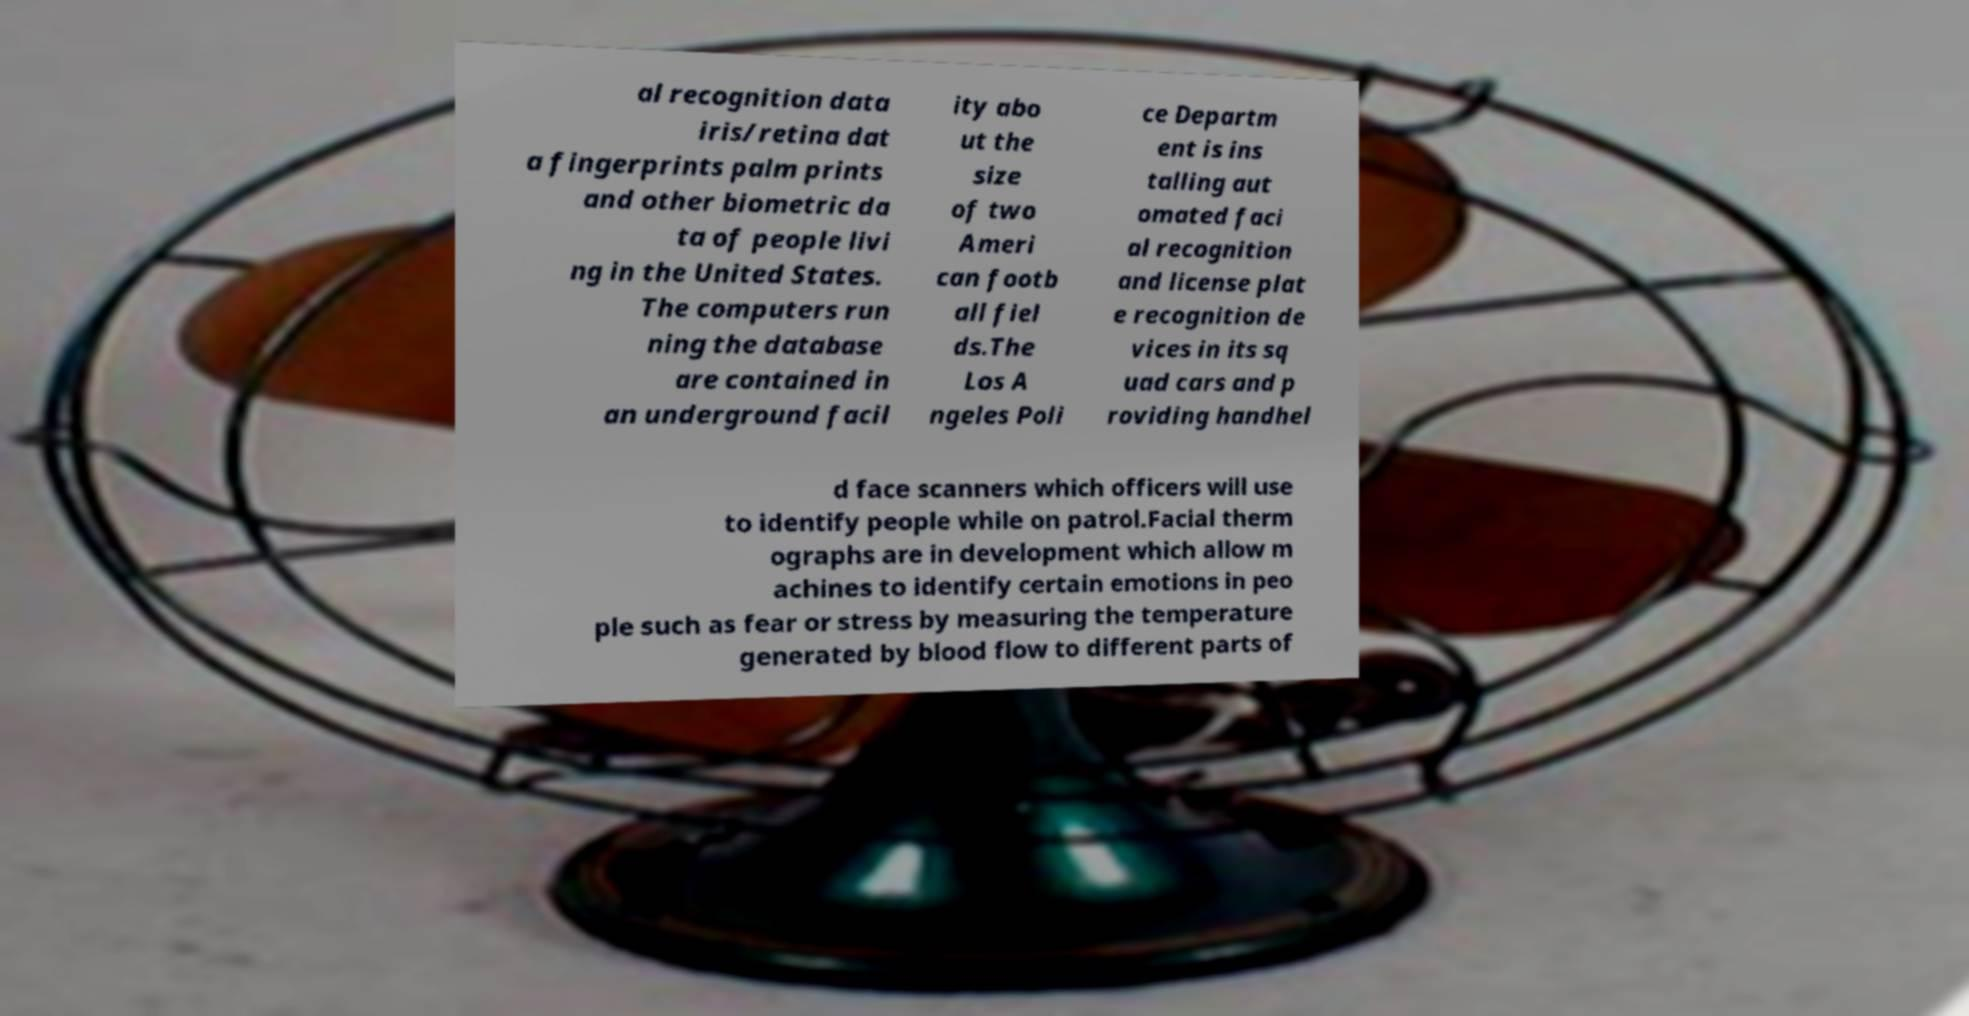Can you read and provide the text displayed in the image?This photo seems to have some interesting text. Can you extract and type it out for me? al recognition data iris/retina dat a fingerprints palm prints and other biometric da ta of people livi ng in the United States. The computers run ning the database are contained in an underground facil ity abo ut the size of two Ameri can footb all fiel ds.The Los A ngeles Poli ce Departm ent is ins talling aut omated faci al recognition and license plat e recognition de vices in its sq uad cars and p roviding handhel d face scanners which officers will use to identify people while on patrol.Facial therm ographs are in development which allow m achines to identify certain emotions in peo ple such as fear or stress by measuring the temperature generated by blood flow to different parts of 